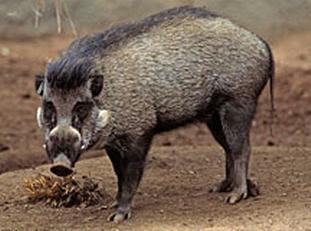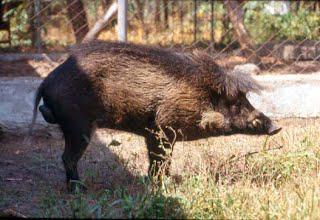The first image is the image on the left, the second image is the image on the right. Analyze the images presented: Is the assertion "There is one mammal facing to the side, and one mammal facing the camera." valid? Answer yes or no. Yes. The first image is the image on the left, the second image is the image on the right. Evaluate the accuracy of this statement regarding the images: "At least one pig has its snout on the ground.". Is it true? Answer yes or no. No. 